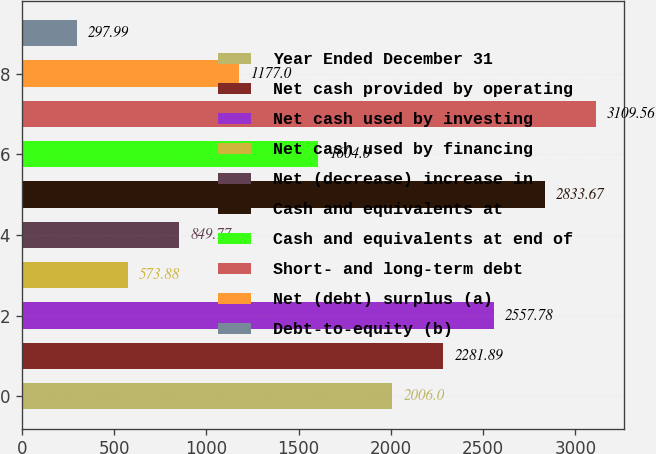Convert chart. <chart><loc_0><loc_0><loc_500><loc_500><bar_chart><fcel>Year Ended December 31<fcel>Net cash provided by operating<fcel>Net cash used by investing<fcel>Net cash used by financing<fcel>Net (decrease) increase in<fcel>Cash and equivalents at<fcel>Cash and equivalents at end of<fcel>Short- and long-term debt<fcel>Net (debt) surplus (a)<fcel>Debt-to-equity (b)<nl><fcel>2006<fcel>2281.89<fcel>2557.78<fcel>573.88<fcel>849.77<fcel>2833.67<fcel>1604<fcel>3109.56<fcel>1177<fcel>297.99<nl></chart> 